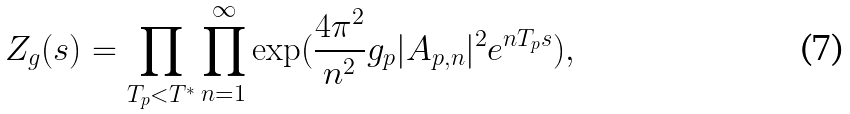<formula> <loc_0><loc_0><loc_500><loc_500>Z _ { g } ( s ) = \prod _ { T _ { p } < T ^ { * } } \prod _ { n = 1 } ^ { \infty } \exp ( \frac { 4 \pi ^ { 2 } } { n ^ { 2 } } g _ { p } | A _ { p , n } | ^ { 2 } e ^ { n T _ { p } s } ) ,</formula> 